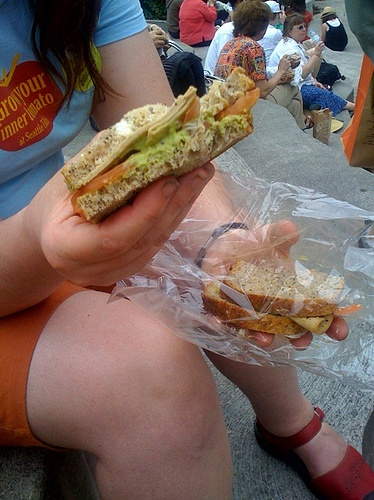Describe the objects in this image and their specific colors. I can see people in navy, gray, darkgray, and maroon tones, sandwich in navy, tan, and olive tones, people in navy, gray, black, and darkgray tones, people in navy, lightblue, gray, and blue tones, and people in navy, brown, and salmon tones in this image. 